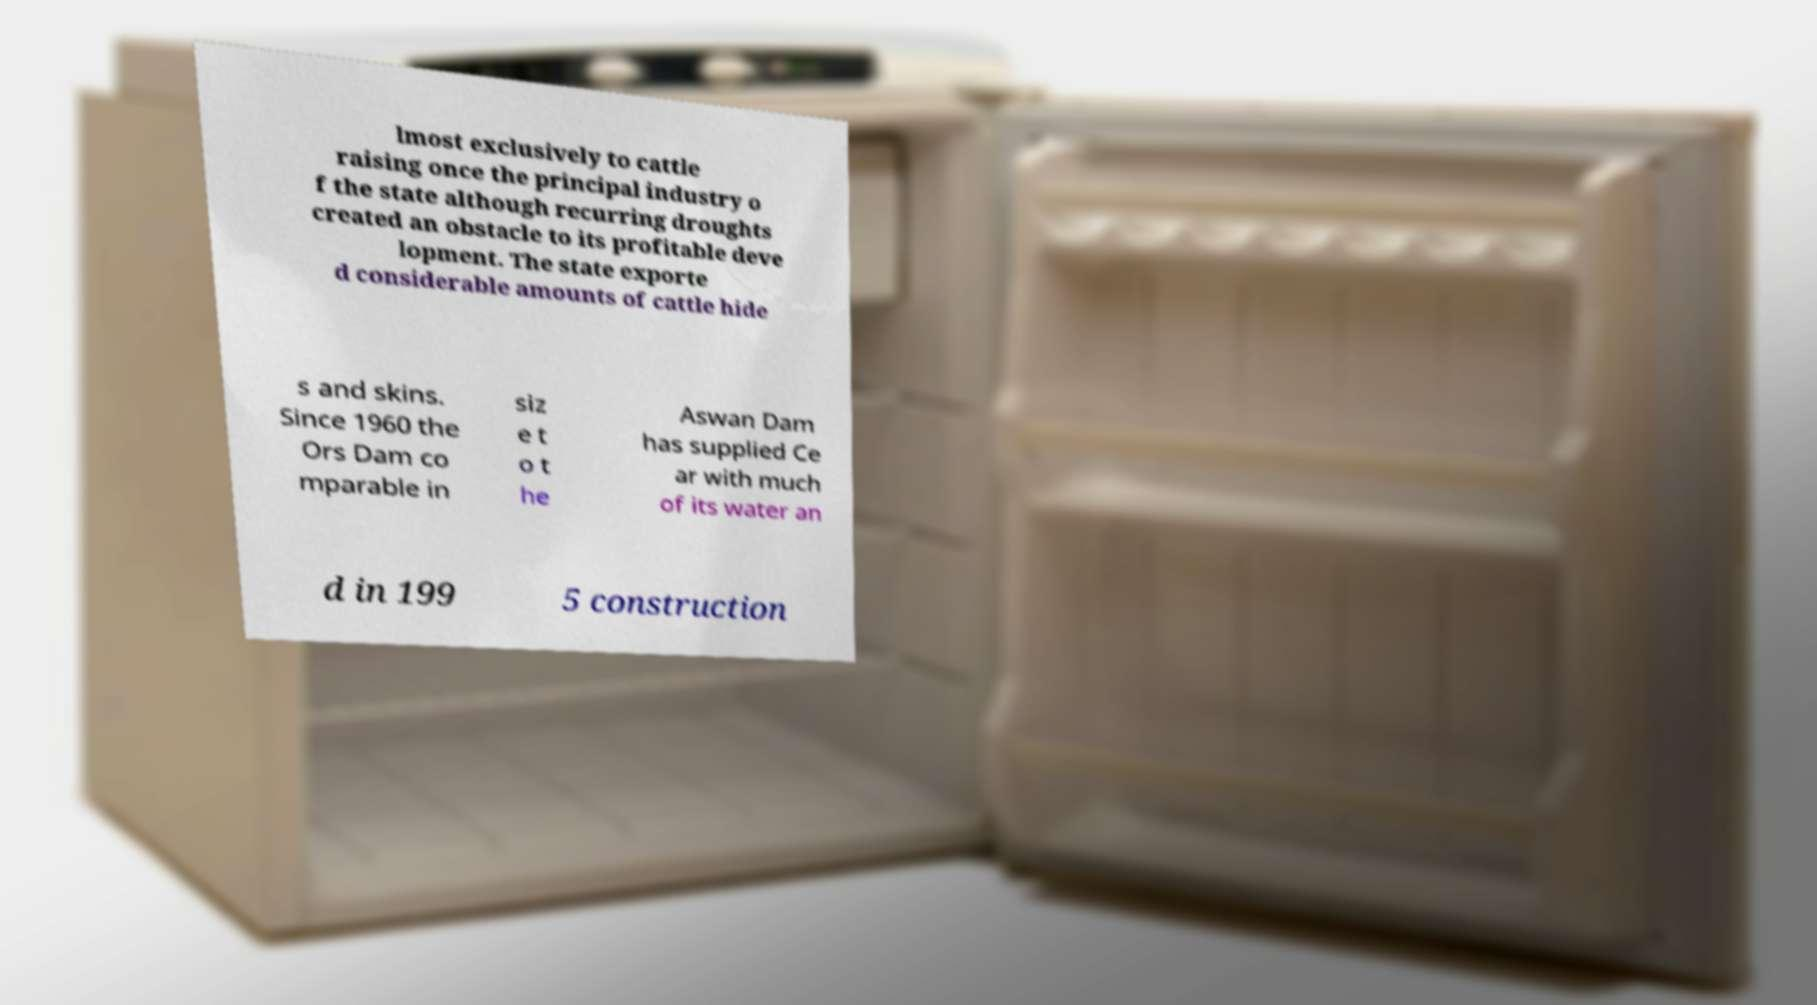Could you extract and type out the text from this image? lmost exclusively to cattle raising once the principal industry o f the state although recurring droughts created an obstacle to its profitable deve lopment. The state exporte d considerable amounts of cattle hide s and skins. Since 1960 the Ors Dam co mparable in siz e t o t he Aswan Dam has supplied Ce ar with much of its water an d in 199 5 construction 